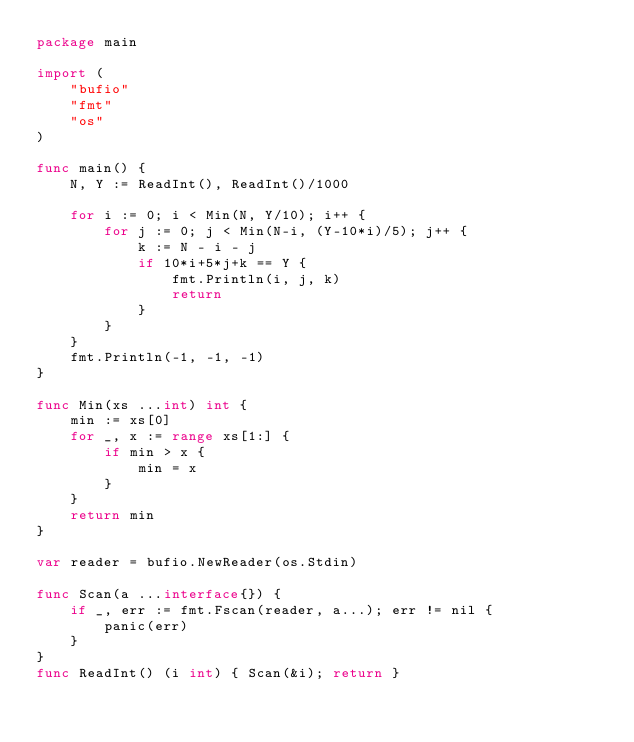<code> <loc_0><loc_0><loc_500><loc_500><_Go_>package main

import (
	"bufio"
	"fmt"
	"os"
)

func main() {
	N, Y := ReadInt(), ReadInt()/1000

	for i := 0; i < Min(N, Y/10); i++ {
		for j := 0; j < Min(N-i, (Y-10*i)/5); j++ {
			k := N - i - j
			if 10*i+5*j+k == Y {
				fmt.Println(i, j, k)
				return
			}
		}
	}
	fmt.Println(-1, -1, -1)
}

func Min(xs ...int) int {
	min := xs[0]
	for _, x := range xs[1:] {
		if min > x {
			min = x
		}
	}
	return min
}

var reader = bufio.NewReader(os.Stdin)

func Scan(a ...interface{}) {
	if _, err := fmt.Fscan(reader, a...); err != nil {
		panic(err)
	}
}
func ReadInt() (i int) { Scan(&i); return }
</code> 